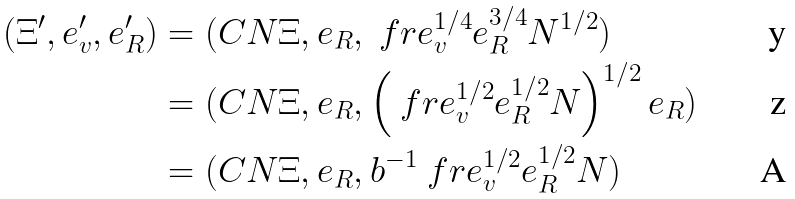<formula> <loc_0><loc_0><loc_500><loc_500>( \Xi ^ { \prime } , e _ { v } ^ { \prime } , e _ { R } ^ { \prime } ) & = ( C N \Xi , e _ { R } , \ f r { e _ { v } ^ { 1 / 4 } e _ { R } ^ { 3 / 4 } } { N ^ { 1 / 2 } } ) \\ & = ( C N \Xi , e _ { R } , \left ( \ f r { e _ { v } ^ { 1 / 2 } } { e _ { R } ^ { 1 / 2 } N } \right ) ^ { 1 / 2 } e _ { R } ) \\ & = ( C N \Xi , e _ { R } , { b } ^ { - 1 } \ f r { e _ { v } ^ { 1 / 2 } e _ { R } ^ { 1 / 2 } } { N } )</formula> 